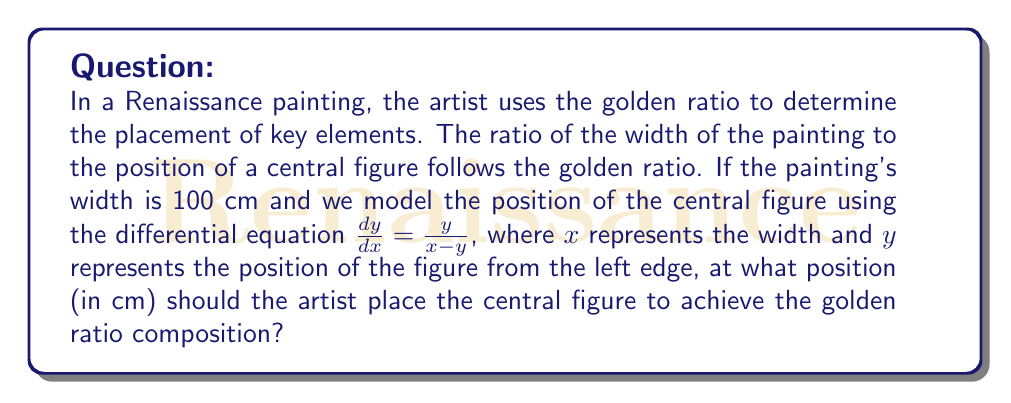Teach me how to tackle this problem. 1. The golden ratio, denoted by $\phi$, is approximately 1.618034. It satisfies the equation:

   $$\phi = 1 + \frac{1}{\phi}$$

2. The differential equation $\frac{dy}{dx} = \frac{y}{x-y}$ models the golden ratio. At the point where the golden ratio is achieved, we have:

   $$\frac{x}{y} = \phi$$

3. Given the width of the painting $x = 100$ cm, we can set up the equation:

   $$\frac{100}{y} = \phi$$

4. Solving for $y$:

   $$y = \frac{100}{\phi}$$

5. Substituting the value of $\phi$:

   $$y = \frac{100}{1.618034} \approx 61.8034 \text{ cm}$$

6. This result confirms the golden ratio property, as:

   $$\frac{100 - 61.8034}{61.8034} \approx 0.618034 = \frac{1}{\phi}$$
Answer: 61.8034 cm 